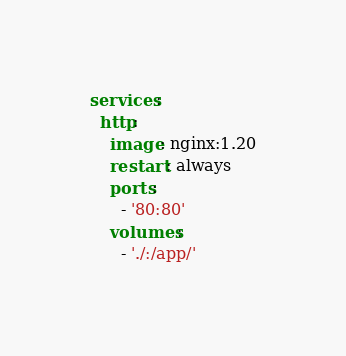<code> <loc_0><loc_0><loc_500><loc_500><_YAML_>services:
  http:
    image: nginx:1.20
    restart: always
    ports:
      - '80:80'
    volumes:
      - './:/app/'</code> 